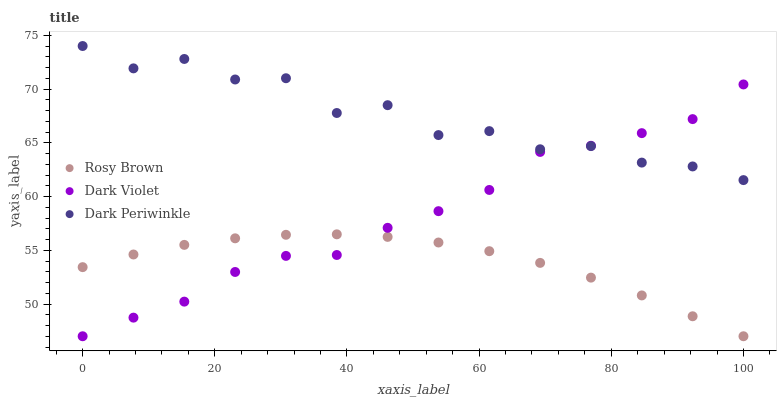Does Rosy Brown have the minimum area under the curve?
Answer yes or no. Yes. Does Dark Periwinkle have the maximum area under the curve?
Answer yes or no. Yes. Does Dark Violet have the minimum area under the curve?
Answer yes or no. No. Does Dark Violet have the maximum area under the curve?
Answer yes or no. No. Is Rosy Brown the smoothest?
Answer yes or no. Yes. Is Dark Periwinkle the roughest?
Answer yes or no. Yes. Is Dark Violet the smoothest?
Answer yes or no. No. Is Dark Violet the roughest?
Answer yes or no. No. Does Rosy Brown have the lowest value?
Answer yes or no. Yes. Does Dark Periwinkle have the lowest value?
Answer yes or no. No. Does Dark Periwinkle have the highest value?
Answer yes or no. Yes. Does Dark Violet have the highest value?
Answer yes or no. No. Is Rosy Brown less than Dark Periwinkle?
Answer yes or no. Yes. Is Dark Periwinkle greater than Rosy Brown?
Answer yes or no. Yes. Does Dark Periwinkle intersect Dark Violet?
Answer yes or no. Yes. Is Dark Periwinkle less than Dark Violet?
Answer yes or no. No. Is Dark Periwinkle greater than Dark Violet?
Answer yes or no. No. Does Rosy Brown intersect Dark Periwinkle?
Answer yes or no. No. 